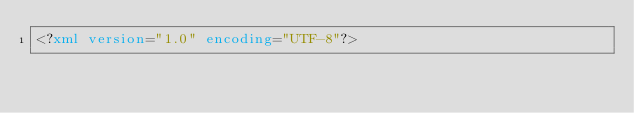<code> <loc_0><loc_0><loc_500><loc_500><_XML_><?xml version="1.0" encoding="UTF-8"?></code> 